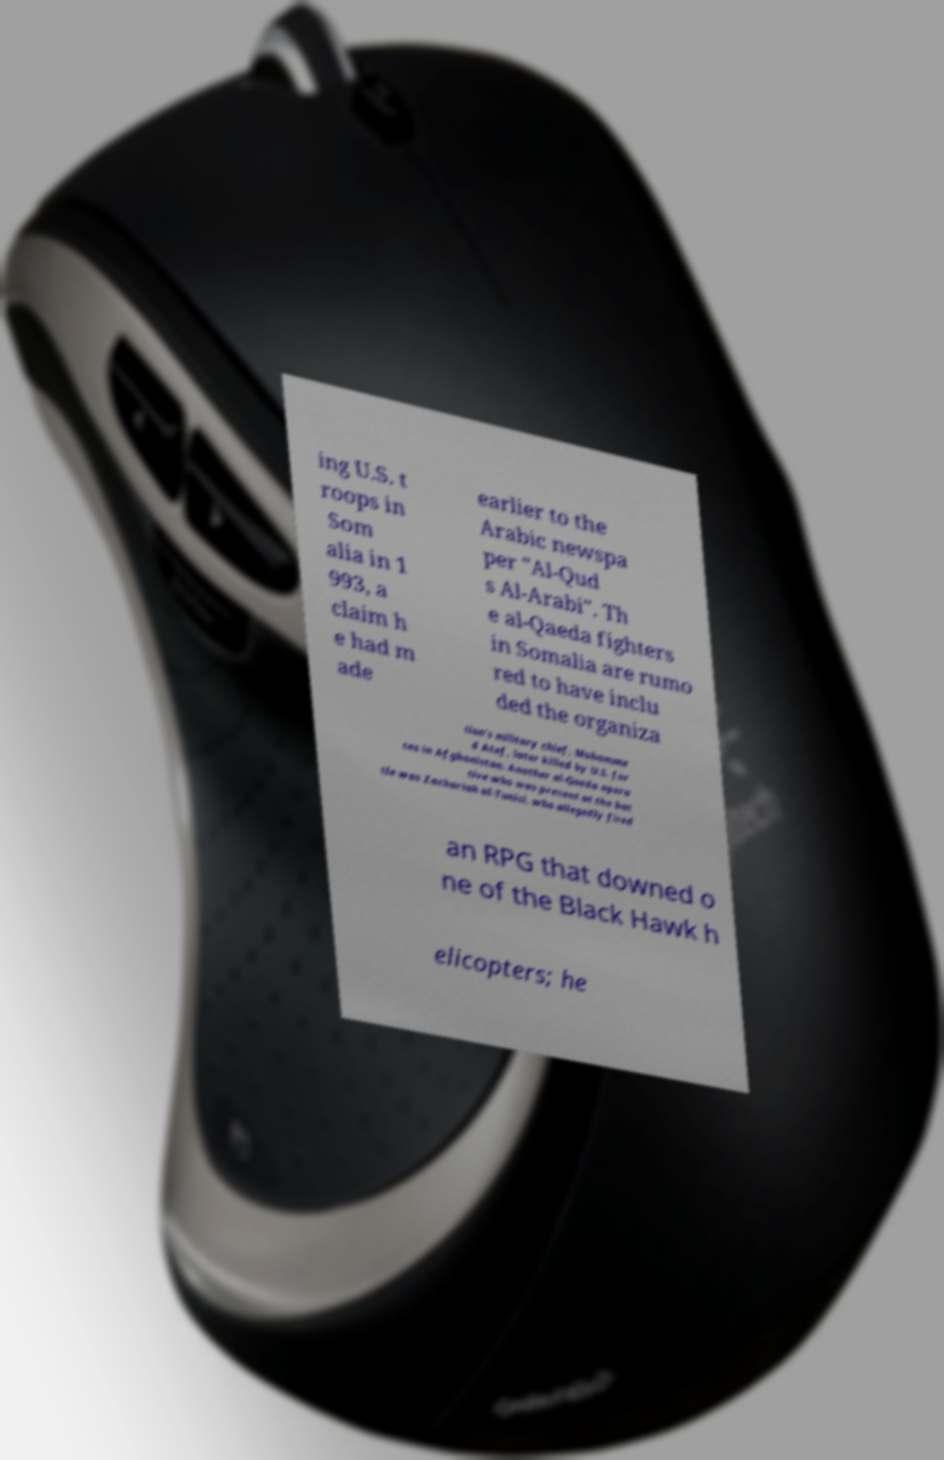There's text embedded in this image that I need extracted. Can you transcribe it verbatim? ing U.S. t roops in Som alia in 1 993, a claim h e had m ade earlier to the Arabic newspa per "Al-Qud s Al-Arabi". Th e al-Qaeda fighters in Somalia are rumo red to have inclu ded the organiza tion's military chief, Mohamme d Atef, later killed by U.S. for ces in Afghanistan. Another al-Qaeda opera tive who was present at the bat tle was Zachariah al-Tunisi, who allegedly fired an RPG that downed o ne of the Black Hawk h elicopters; he 